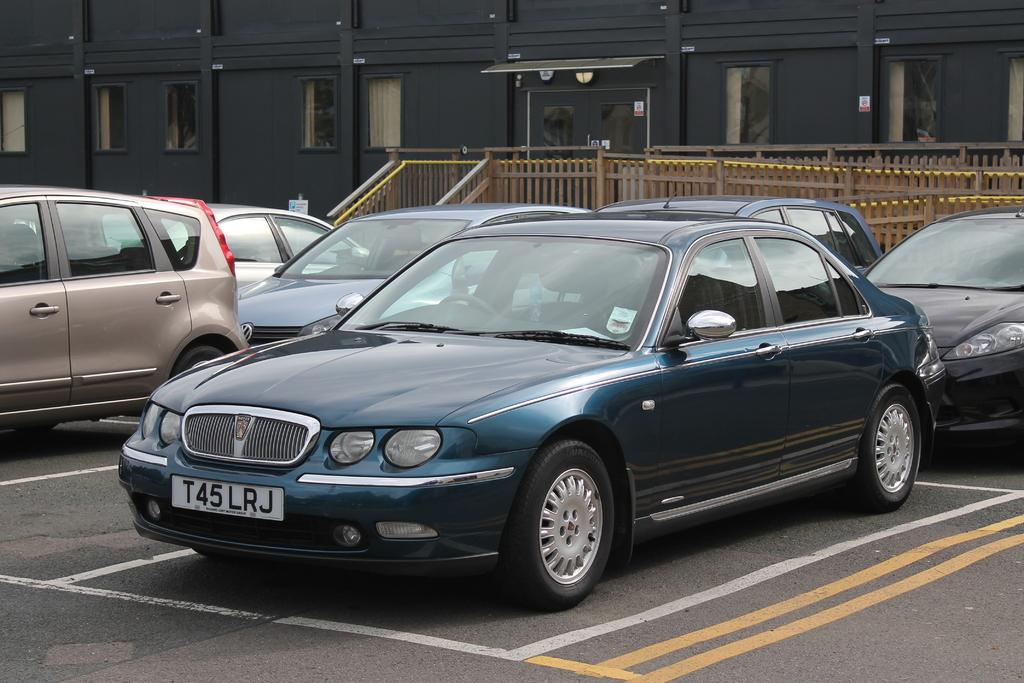What can be seen on the road in the image? There are cars parked on the road in the image. What is behind the parked cars? There is a wooden fence behind the cars. What is visible in the background of the image? There is a building in the background of the image. How does the cushion help the cars fly in the image? There is no cushion present in the image, and the cars are not flying. 